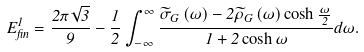<formula> <loc_0><loc_0><loc_500><loc_500>E _ { f i n } ^ { 1 } = \frac { 2 \pi \sqrt { 3 } } 9 - \frac { 1 } { 2 } \int _ { - \infty } ^ { \infty } \frac { \widetilde { \sigma } _ { G } \left ( \omega \right ) - 2 \widetilde { \rho } _ { G } \left ( \omega \right ) \cosh \frac { \omega } { 2 } } { 1 + 2 \cosh \omega } d \omega .</formula> 